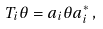Convert formula to latex. <formula><loc_0><loc_0><loc_500><loc_500>T _ { i } \theta = a _ { i } \theta a _ { i } ^ { * } \, ,</formula> 